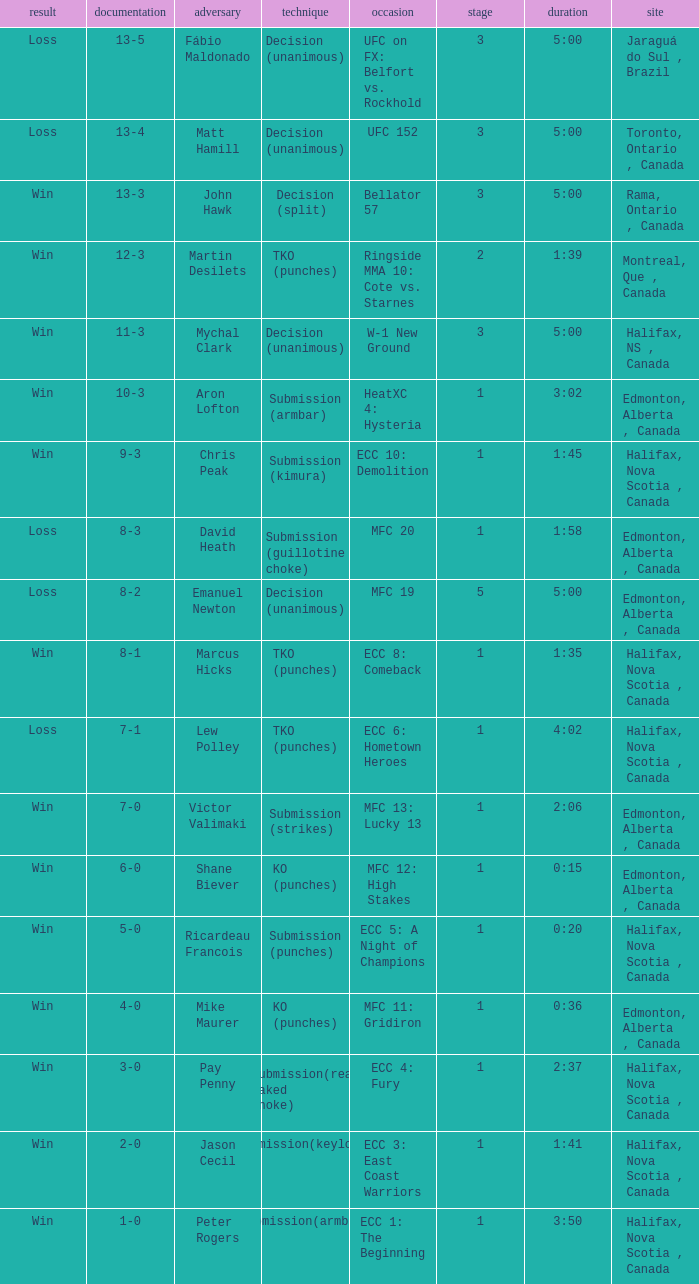What is the round of the match with Emanuel Newton as the opponent? 5.0. 